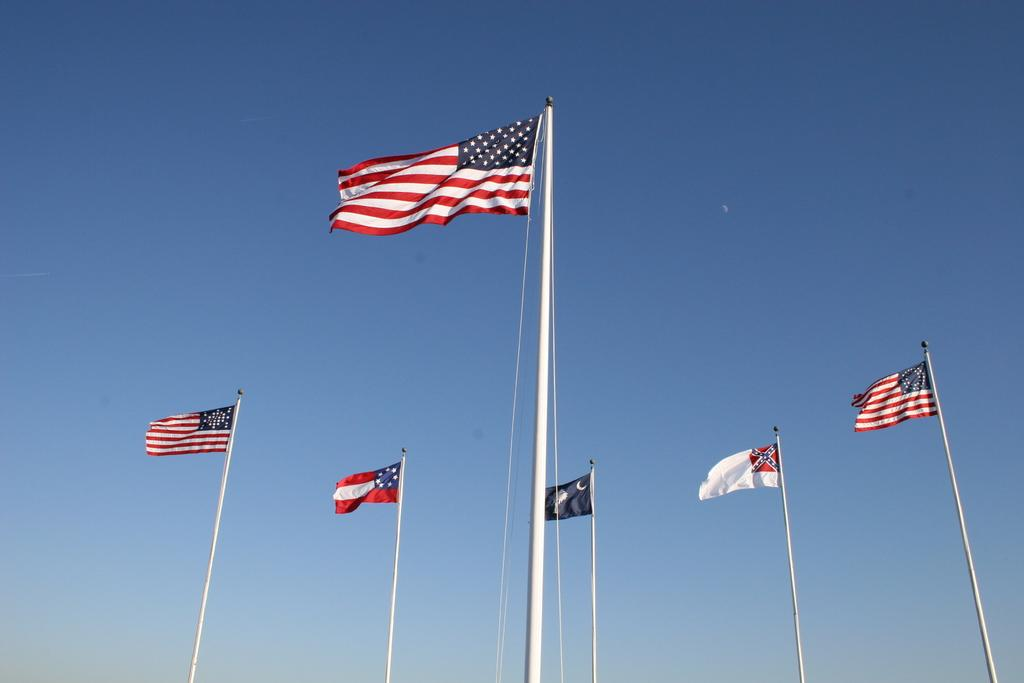What can be seen in the image that represents different countries or organizations? There are different types of flags in the image. What part of the natural environment is visible in the image? The sky is visible in the background of the image. What type of soup is being served in the frame in the image? There is no soup or frame present in the image; it features different types of flags and the sky in the background. 